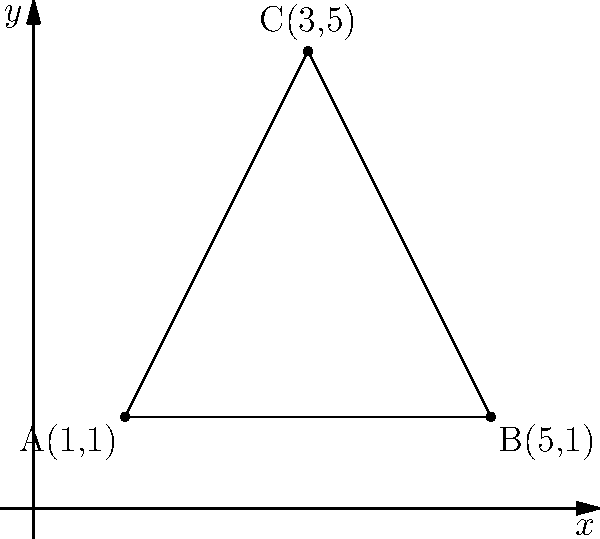Hey there, chill friend! Check out this triangle ABC on the coordinate plane. Can you figure out its area without breaking a sweat? Just eyeball the coordinates and work some quick math magic! Alright, let's break this down step-by-step:

1) We can use the formula for the area of a triangle given three points:
   Area = $\frac{1}{2}|x_1(y_2 - y_3) + x_2(y_3 - y_1) + x_3(y_1 - y_2)|$

2) We have:
   A(1,1), B(5,1), C(3,5)
   So, $(x_1,y_1) = (1,1)$, $(x_2,y_2) = (5,1)$, $(x_3,y_3) = (3,5)$

3) Let's plug these into our formula:
   Area = $\frac{1}{2}|1(1 - 5) + 5(5 - 1) + 3(1 - 1)|$

4) Simplify inside the parentheses:
   Area = $\frac{1}{2}|1(-4) + 5(4) + 3(0)|$

5) Multiply:
   Area = $\frac{1}{2}|-4 + 20 + 0|$

6) Add inside the absolute value signs:
   Area = $\frac{1}{2}|16|$

7) The absolute value of 16 is just 16:
   Area = $\frac{1}{2}(16)$

8) Finally, divide:
   Area = 8

So, the area of the triangle is 8 square units.
Answer: 8 square units 